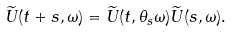Convert formula to latex. <formula><loc_0><loc_0><loc_500><loc_500>\widetilde { U } ( t + s , \omega ) = \widetilde { U } ( t , \theta _ { s } \omega ) \widetilde { U } ( s , \omega ) .</formula> 